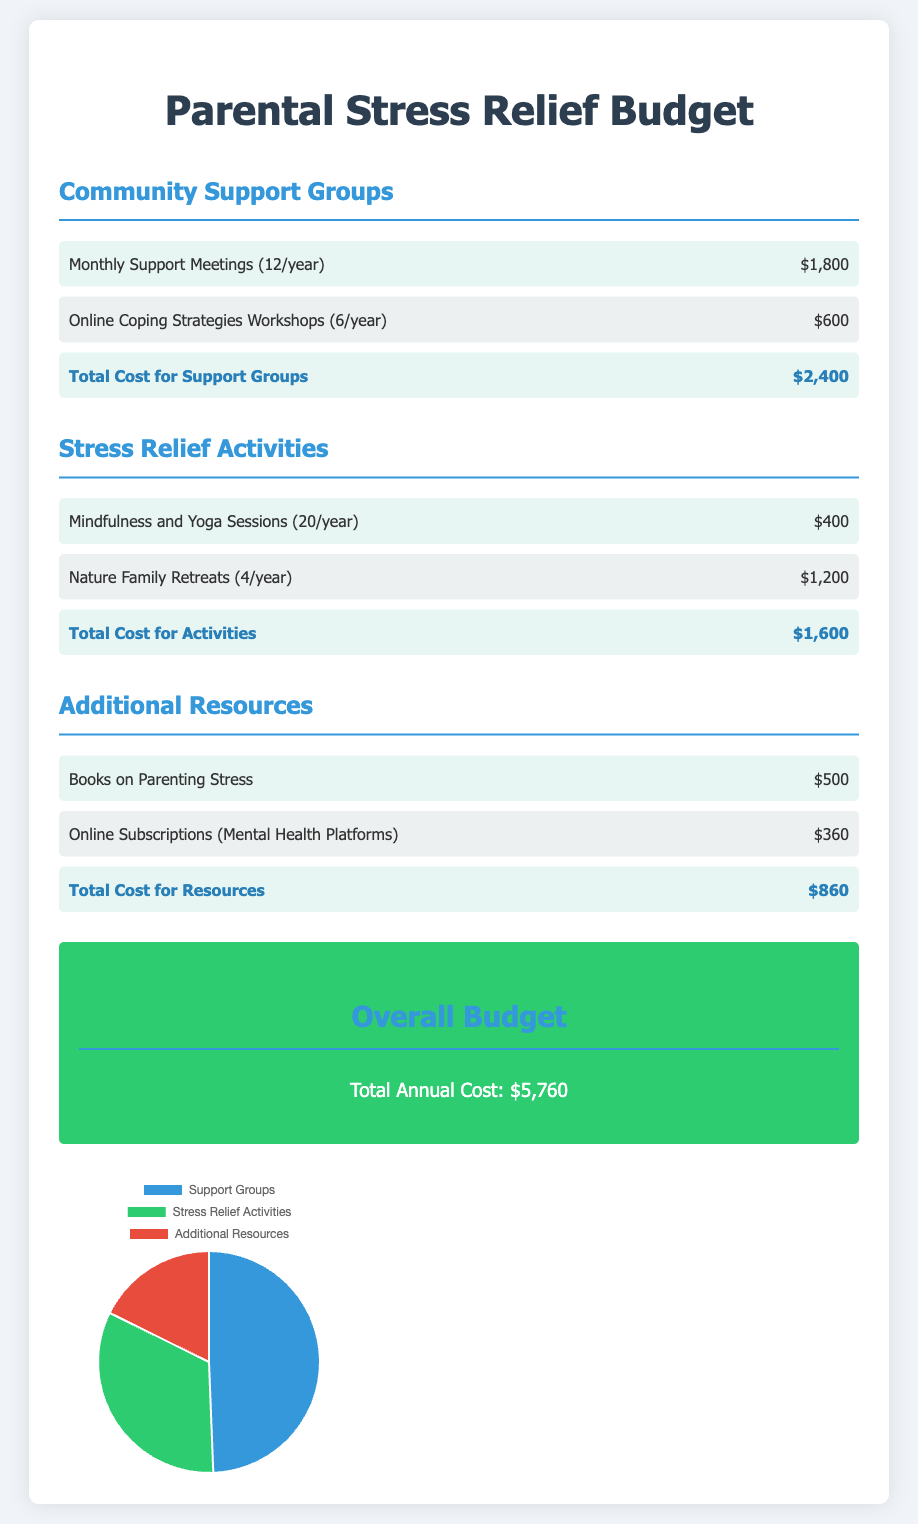What is the total cost for support groups? The total cost for support groups is provided in the document as the sum of the monthly meetings and workshops, which is $1,800 + $600.
Answer: $2,400 How many online coping strategies workshops are held per year? The document specifies that there are 6 online coping strategies workshops held per year.
Answer: 6 What is the cost of nature family retreats? The document states that the cost of nature family retreats is $1,200 for 4 per year.
Answer: $1,200 What is the total annual cost for all activities? The overall budget at the end of the document provides the total annual costs for community support groups, stress relief activities, and additional resources.
Answer: $5,760 What percentage of the overall budget is allocated to additional resources? To determine the percentage, we compare the cost of additional resources ($860) to the total budget ($5,760). The calculation would show the proportion.
Answer: Approximately 15% How many mindfulness and yoga sessions are conducted each year? The document indicates that there are 20 mindfulness and yoga sessions conducted each year.
Answer: 20 What type of document is this? The document is a budget overview pertaining to parental stress relief initiatives.
Answer: Budget overview Which category has the highest cost? By observing the budget sections, the category that has the highest cost is identified.
Answer: Community Support Groups 